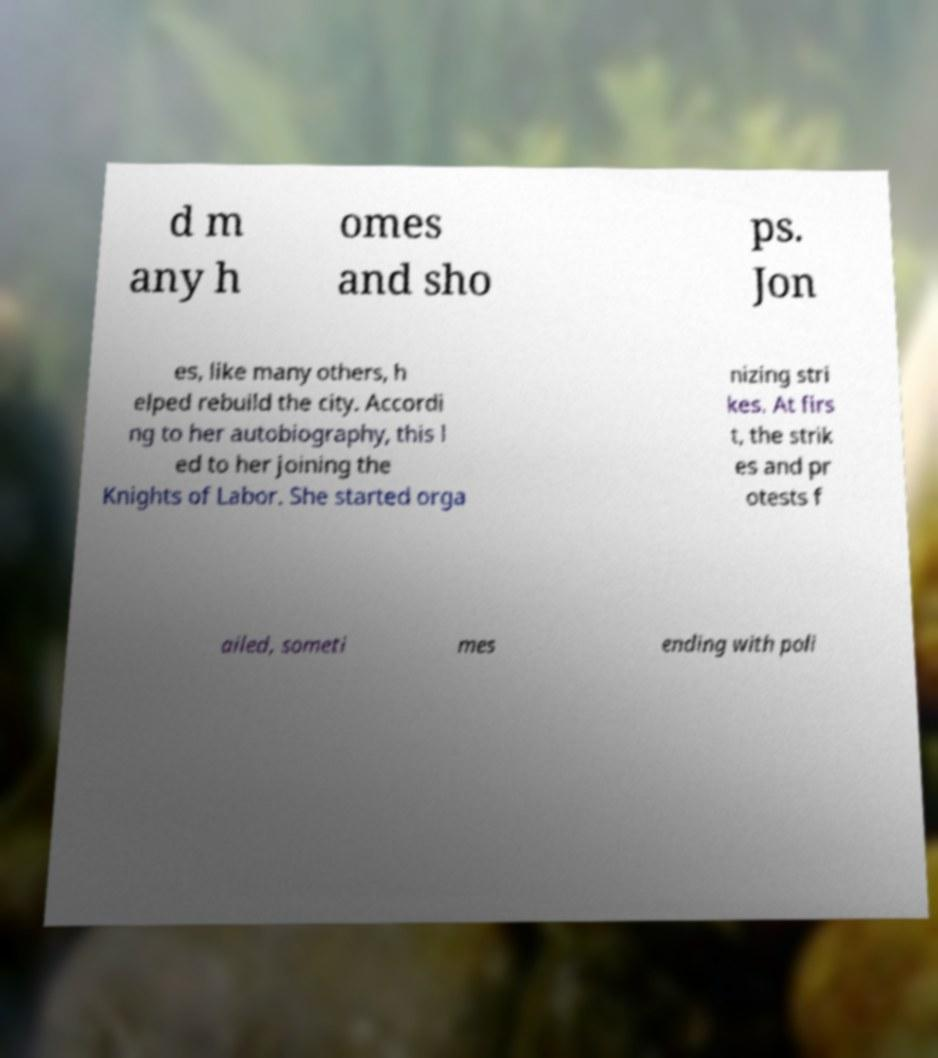Please identify and transcribe the text found in this image. d m any h omes and sho ps. Jon es, like many others, h elped rebuild the city. Accordi ng to her autobiography, this l ed to her joining the Knights of Labor. She started orga nizing stri kes. At firs t, the strik es and pr otests f ailed, someti mes ending with poli 